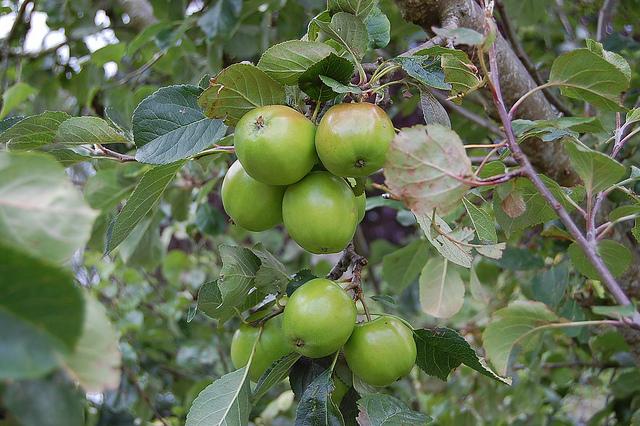Is this an orange Grove?
Be succinct. No. How many apple are on the tree?
Answer briefly. 7. What kind of tree is this?
Short answer required. Apple. What color are the fruits?
Give a very brief answer. Green. What is this plant?
Quick response, please. Apple. What fruit is this?
Short answer required. Apple. Is this an apple?
Quick response, please. Yes. What is growing on the tree?
Concise answer only. Apples. Is this a citrus fruit?
Write a very short answer. No. What kind of fruit is on the tree?
Quick response, please. Apple. What type of tree is it?
Answer briefly. Apple. 